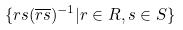Convert formula to latex. <formula><loc_0><loc_0><loc_500><loc_500>\{ r s ( \overline { r s } ) ^ { - 1 } | r \in R , s \in S \}</formula> 